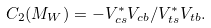Convert formula to latex. <formula><loc_0><loc_0><loc_500><loc_500>C _ { 2 } ( M _ { W } ) = - V _ { c s } ^ { \ast } V _ { c b } / V _ { t s } ^ { \ast } V _ { t b } .</formula> 